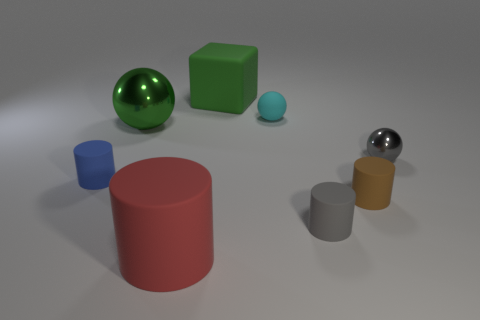Do the cyan sphere and the gray thing that is in front of the tiny blue thing have the same material?
Your answer should be compact. Yes. Is the number of gray cylinders that are left of the tiny gray cylinder less than the number of tiny cyan objects on the left side of the red rubber cylinder?
Keep it short and to the point. No. Is there a shiny sphere on the right side of the green object on the left side of the large matte object behind the blue thing?
Give a very brief answer. Yes. Does the tiny metallic thing have the same shape as the tiny rubber object behind the blue cylinder?
Your answer should be compact. Yes. Are there any large red things that have the same shape as the tiny brown matte thing?
Your answer should be very brief. Yes. There is a brown thing that is the same size as the cyan matte ball; what is its shape?
Ensure brevity in your answer.  Cylinder. Is the big ball the same color as the big cube?
Your response must be concise. Yes. How big is the gray thing that is in front of the gray metallic ball?
Offer a terse response. Small. Is the size of the gray object in front of the blue thing the same as the small cyan matte object?
Your answer should be very brief. Yes. What is the size of the gray rubber cylinder?
Give a very brief answer. Small. 